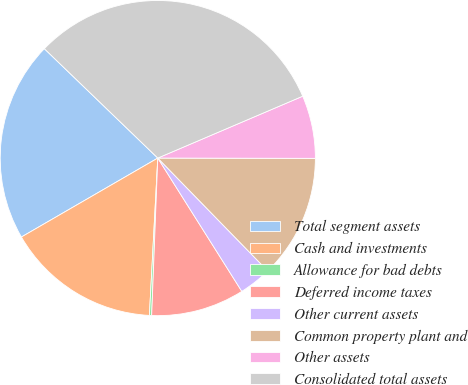Convert chart to OTSL. <chart><loc_0><loc_0><loc_500><loc_500><pie_chart><fcel>Total segment assets<fcel>Cash and investments<fcel>Allowance for bad debts<fcel>Deferred income taxes<fcel>Other current assets<fcel>Common property plant and<fcel>Other assets<fcel>Consolidated total assets<nl><fcel>20.56%<fcel>15.8%<fcel>0.23%<fcel>9.57%<fcel>3.34%<fcel>12.68%<fcel>6.45%<fcel>31.37%<nl></chart> 